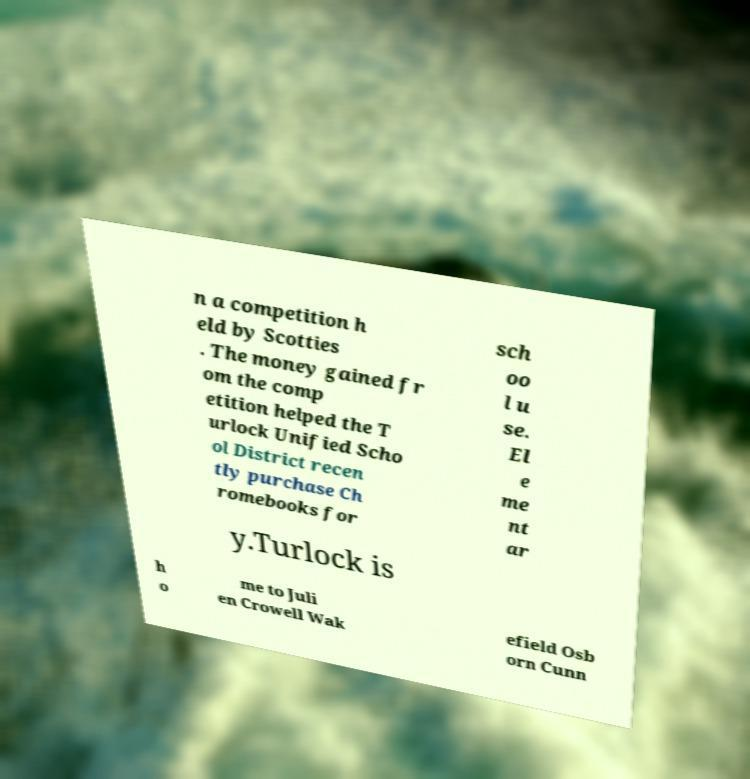There's text embedded in this image that I need extracted. Can you transcribe it verbatim? n a competition h eld by Scotties . The money gained fr om the comp etition helped the T urlock Unified Scho ol District recen tly purchase Ch romebooks for sch oo l u se. El e me nt ar y.Turlock is h o me to Juli en Crowell Wak efield Osb orn Cunn 